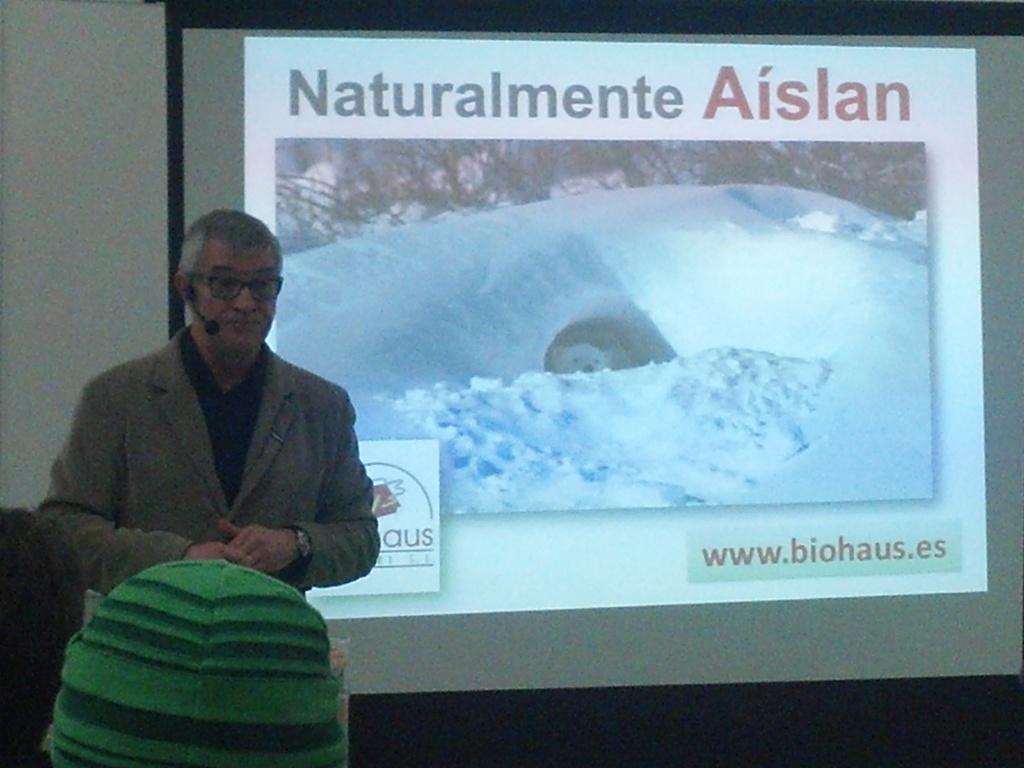Describe this image in one or two sentences. As we can see in the image there is a wall, screen and a man standing over here. 